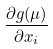Convert formula to latex. <formula><loc_0><loc_0><loc_500><loc_500>\frac { \partial g ( \mu ) } { \partial x _ { i } }</formula> 